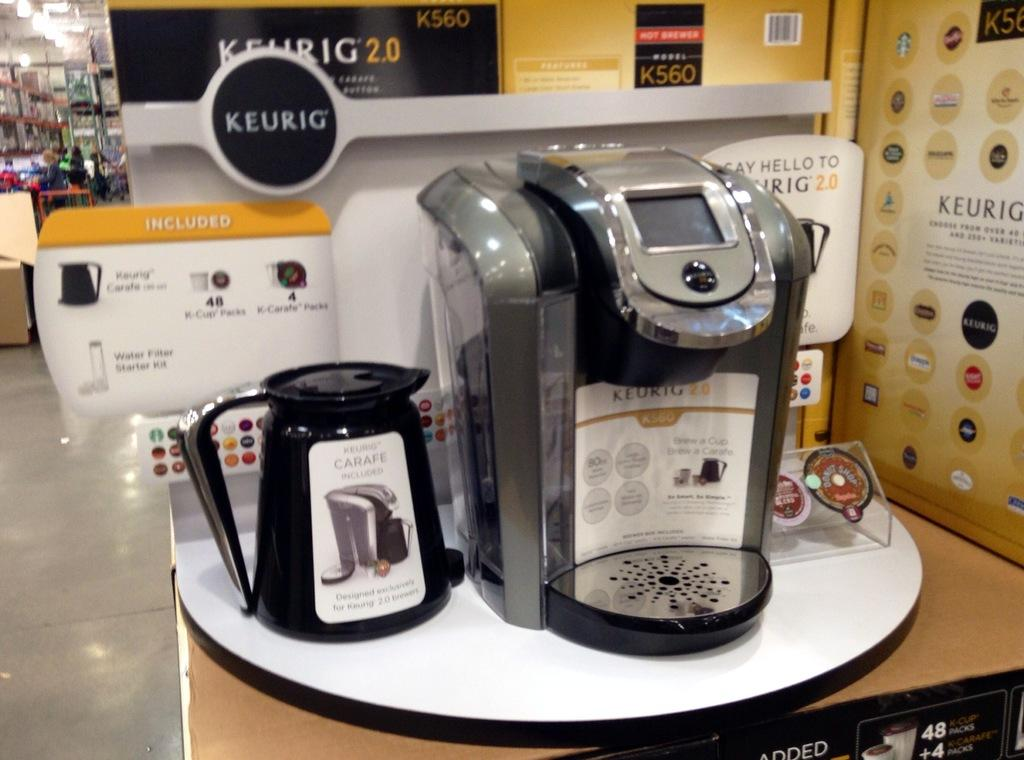<image>
Create a compact narrative representing the image presented. The K cup machine sitting on the table is made by Keurig. 